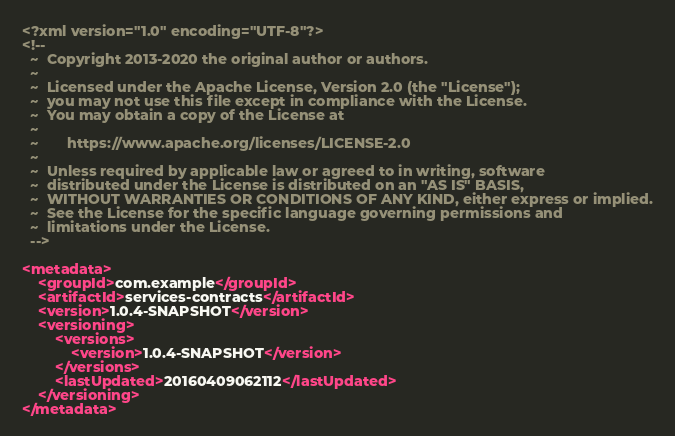<code> <loc_0><loc_0><loc_500><loc_500><_XML_><?xml version="1.0" encoding="UTF-8"?>
<!--
  ~  Copyright 2013-2020 the original author or authors.
  ~
  ~  Licensed under the Apache License, Version 2.0 (the "License");
  ~  you may not use this file except in compliance with the License.
  ~  You may obtain a copy of the License at
  ~
  ~       https://www.apache.org/licenses/LICENSE-2.0
  ~
  ~  Unless required by applicable law or agreed to in writing, software
  ~  distributed under the License is distributed on an "AS IS" BASIS,
  ~  WITHOUT WARRANTIES OR CONDITIONS OF ANY KIND, either express or implied.
  ~  See the License for the specific language governing permissions and
  ~  limitations under the License.
  -->

<metadata>
	<groupId>com.example</groupId>
	<artifactId>services-contracts</artifactId>
	<version>1.0.4-SNAPSHOT</version>
	<versioning>
		<versions>
			<version>1.0.4-SNAPSHOT</version>
		</versions>
		<lastUpdated>20160409062112</lastUpdated>
	</versioning>
</metadata>
</code> 